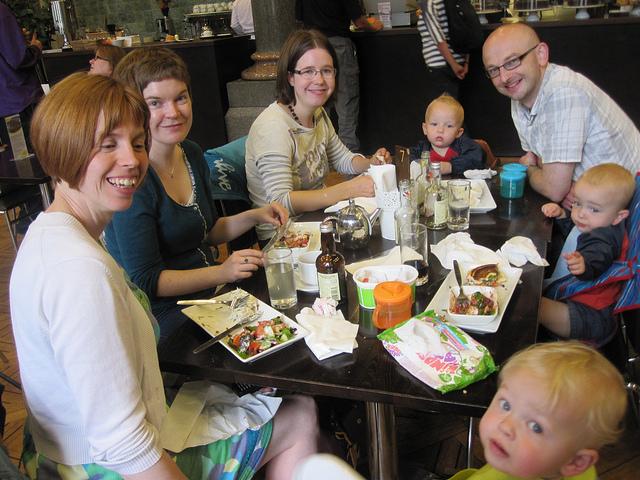How many people are wearing glasses in this scene?
Be succinct. 2. What is the seated woman wearing on her left wrist?
Write a very short answer. Nothing. What is the bottle in the front?
Short answer required. Wine. How many women are at the table?
Write a very short answer. 3. How many men in the photo?
Keep it brief. 1. What color are the child's eyes looking behind to the camera?
Keep it brief. Blue. Why do you think some people might be drinking coffee?
Write a very short answer. Coffee cup. Is it an eating contest or a restaurant?
Answer briefly. Restaurant. What are their forks made out of?
Give a very brief answer. Metal. Are the kids having fun?
Keep it brief. Yes. How many children are there?
Be succinct. 3. Do the people look happy?
Answer briefly. Yes. Are all the people looking at the camera?
Short answer required. Yes. Has the food been served?
Short answer required. Yes. Are the children wearing uniforms?
Be succinct. No. 